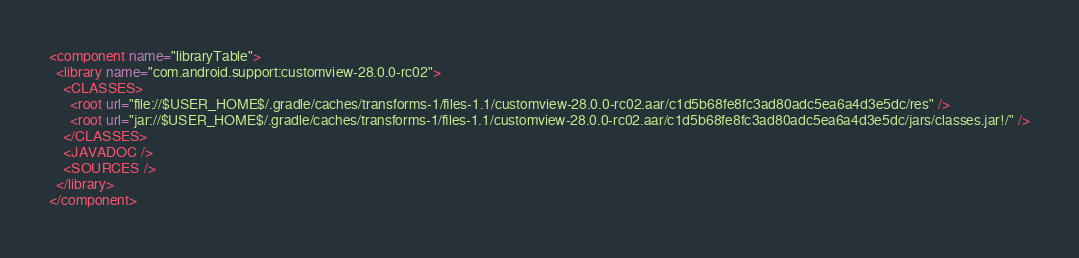Convert code to text. <code><loc_0><loc_0><loc_500><loc_500><_XML_><component name="libraryTable">
  <library name="com.android.support:customview-28.0.0-rc02">
    <CLASSES>
      <root url="file://$USER_HOME$/.gradle/caches/transforms-1/files-1.1/customview-28.0.0-rc02.aar/c1d5b68fe8fc3ad80adc5ea6a4d3e5dc/res" />
      <root url="jar://$USER_HOME$/.gradle/caches/transforms-1/files-1.1/customview-28.0.0-rc02.aar/c1d5b68fe8fc3ad80adc5ea6a4d3e5dc/jars/classes.jar!/" />
    </CLASSES>
    <JAVADOC />
    <SOURCES />
  </library>
</component></code> 